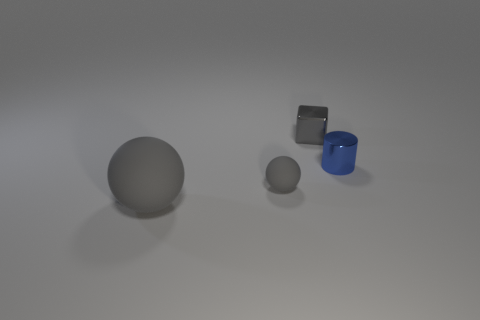Add 3 gray matte objects. How many objects exist? 7 Subtract all cubes. How many objects are left? 3 Add 3 gray spheres. How many gray spheres are left? 5 Add 2 small shiny cubes. How many small shiny cubes exist? 3 Subtract 2 gray spheres. How many objects are left? 2 Subtract all brown blocks. Subtract all blue shiny cylinders. How many objects are left? 3 